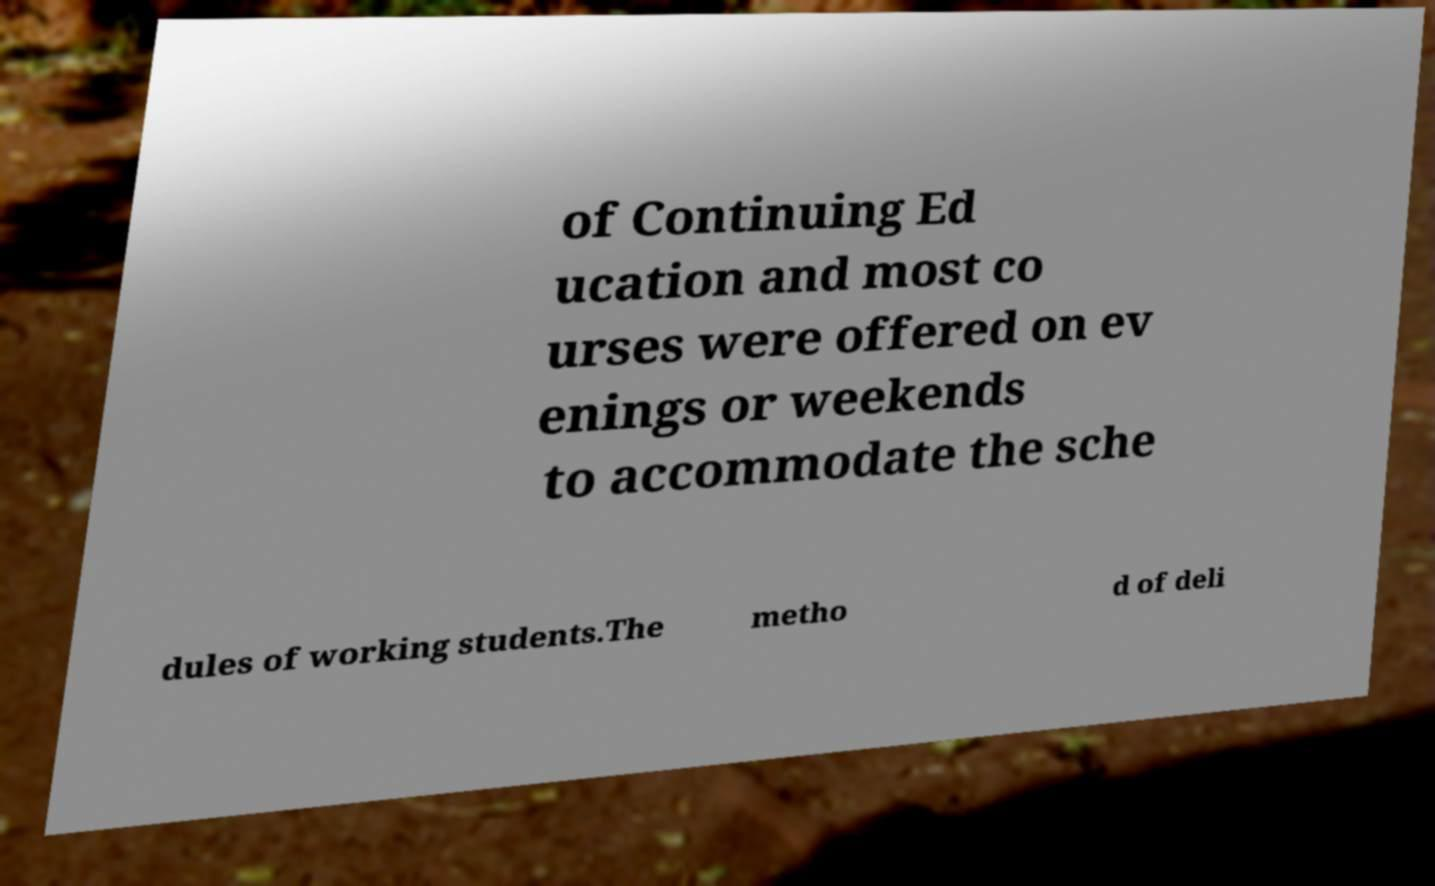Please identify and transcribe the text found in this image. of Continuing Ed ucation and most co urses were offered on ev enings or weekends to accommodate the sche dules of working students.The metho d of deli 